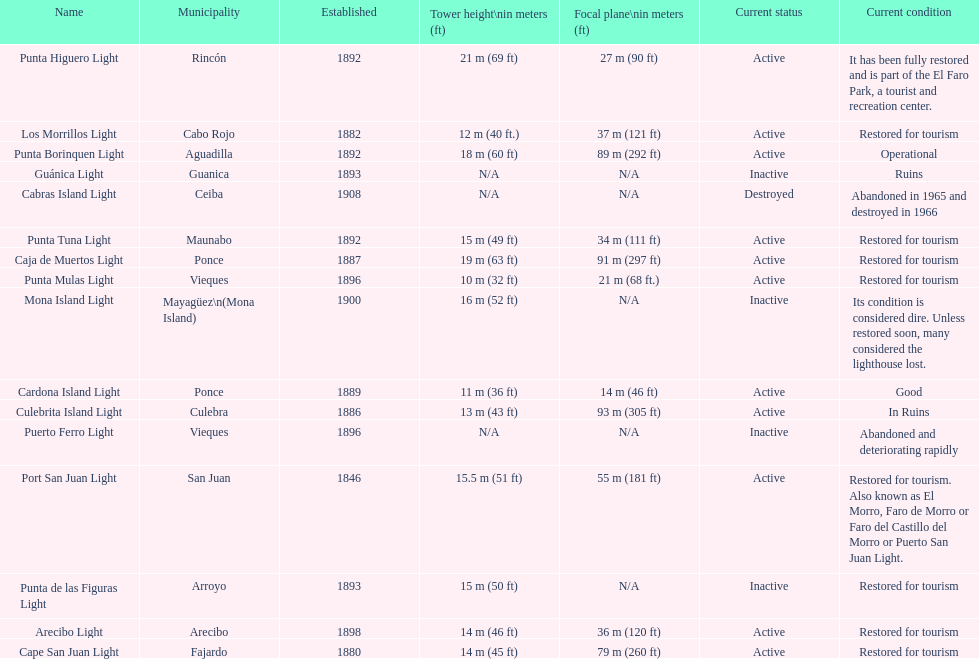What is the number of establishments that have been restored for tourism purposes? 9. 